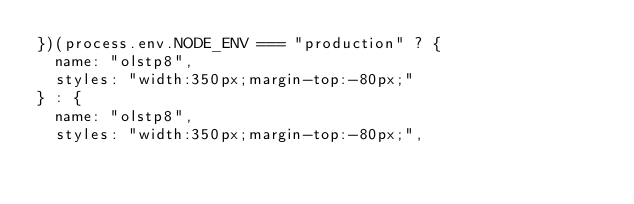Convert code to text. <code><loc_0><loc_0><loc_500><loc_500><_JavaScript_>})(process.env.NODE_ENV === "production" ? {
  name: "olstp8",
  styles: "width:350px;margin-top:-80px;"
} : {
  name: "olstp8",
  styles: "width:350px;margin-top:-80px;",</code> 